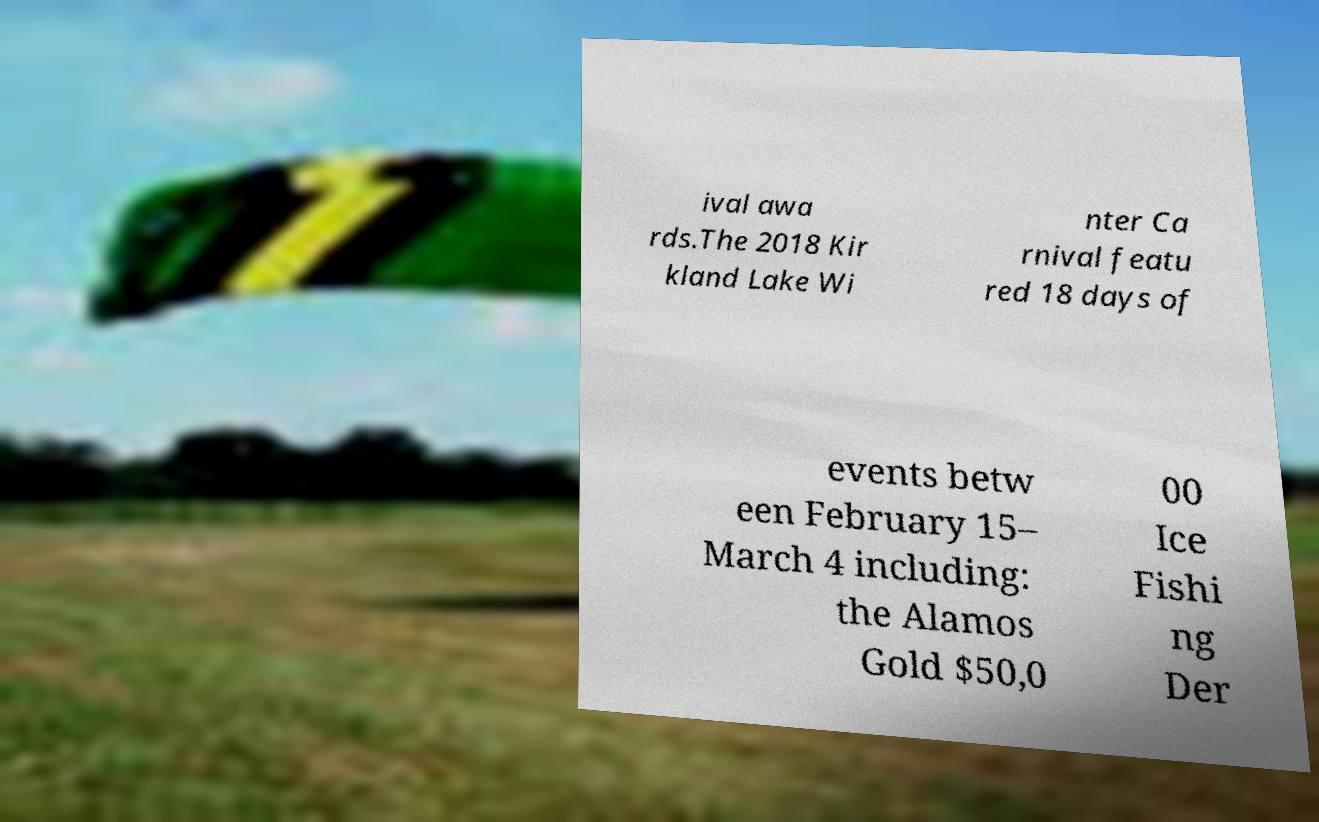There's text embedded in this image that I need extracted. Can you transcribe it verbatim? ival awa rds.The 2018 Kir kland Lake Wi nter Ca rnival featu red 18 days of events betw een February 15– March 4 including: the Alamos Gold $50,0 00 Ice Fishi ng Der 